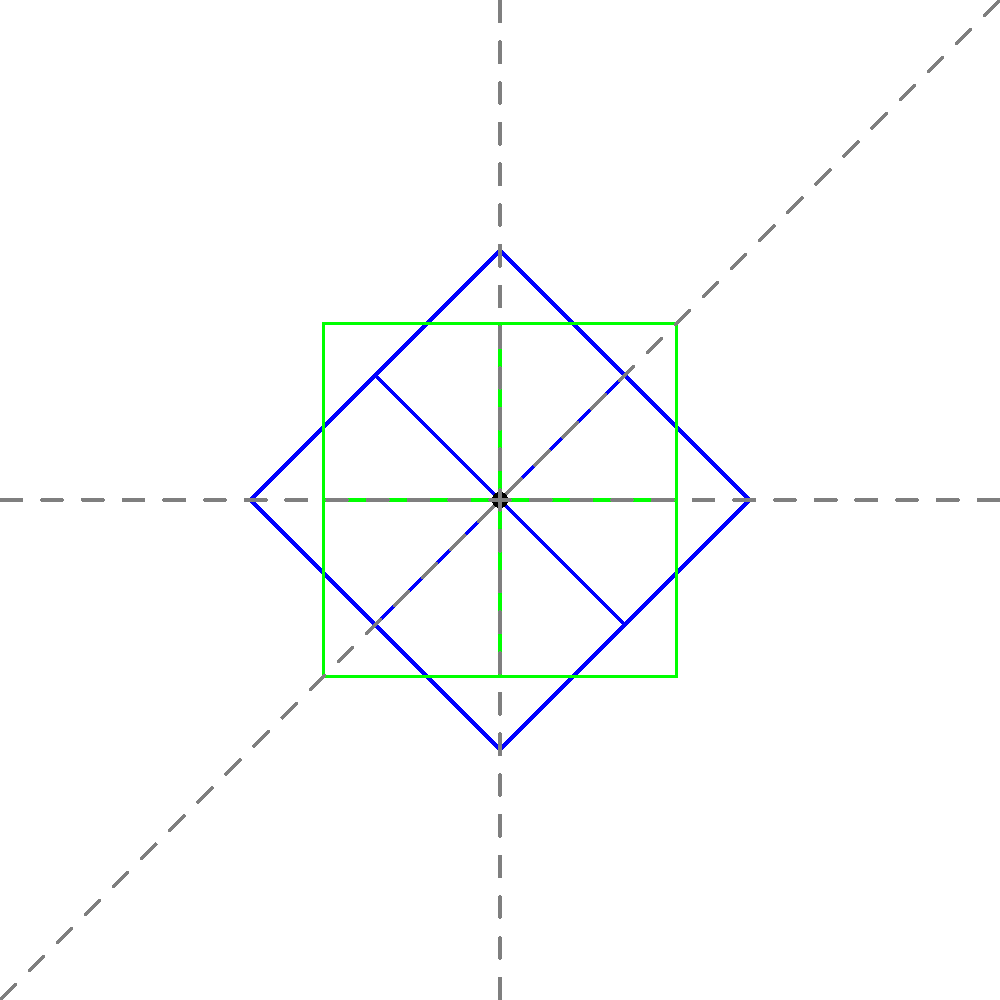A complex gear shape undergoes multiple transformations. The original gear (blue) is first rotated 45° counterclockwise (red), then reflected across the line $y=x$ (green). Determine the symmetry of the final shape (green) with respect to the origin (0,0). To determine the symmetry of the final shape with respect to the origin, we need to analyze the transformations and their effects on the original gear:

1. The original gear (blue) has 4-fold rotational symmetry about the origin.

2. After rotating 45° counterclockwise (red):
   - The 4-fold rotational symmetry is preserved.
   - The shape is now aligned with the diagonal lines.

3. Reflecting across the line $y=x$ (green):
   - This reflection maps points $(x,y)$ to $(y,x)$.
   - It effectively rotates the shape 90° about the line $y=x$.

4. Analyzing the final shape (green):
   - The 4-fold rotational symmetry is still preserved.
   - The shape is symmetric about both the x-axis and y-axis.
   - It is also symmetric about both diagonal lines $y=x$ and $y=-x$.

5. Conclusion:
   - The final shape has 4-fold rotational symmetry about the origin.
   - It also has reflectional symmetry about the x-axis, y-axis, and both diagonal lines.

Therefore, the final shape exhibits full symmetry about the origin, known as point symmetry or 4-fold rotational symmetry with 4 lines of reflection.
Answer: 4-fold rotational symmetry with 4 lines of reflection 